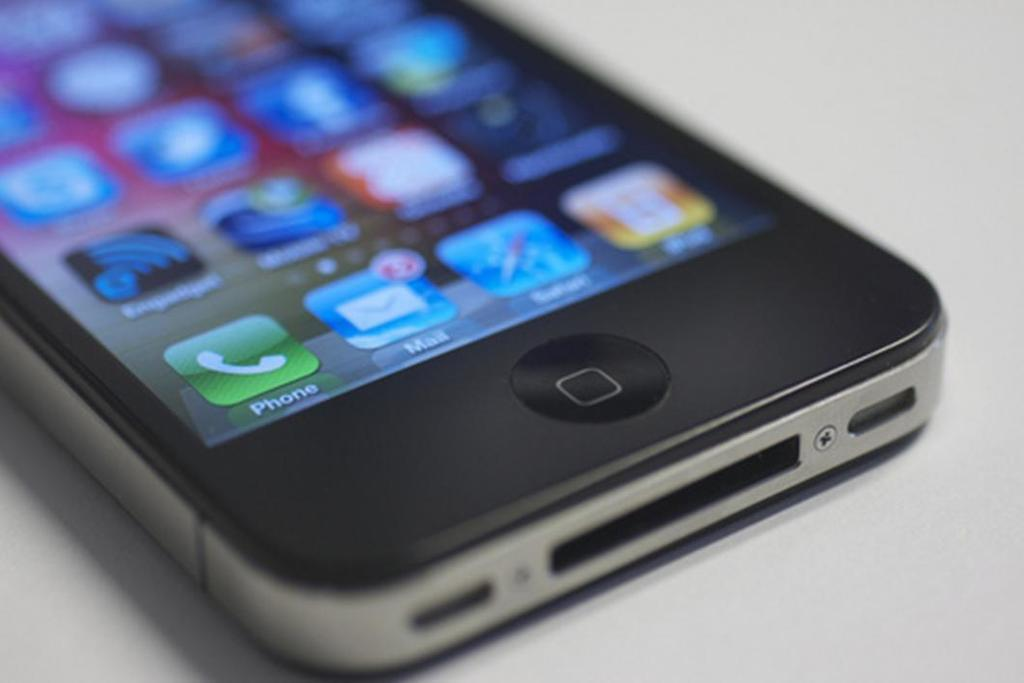<image>
Relay a brief, clear account of the picture shown. A black smartphone lying on a counter with the display screen showing and the phone and mail icon displayed. 